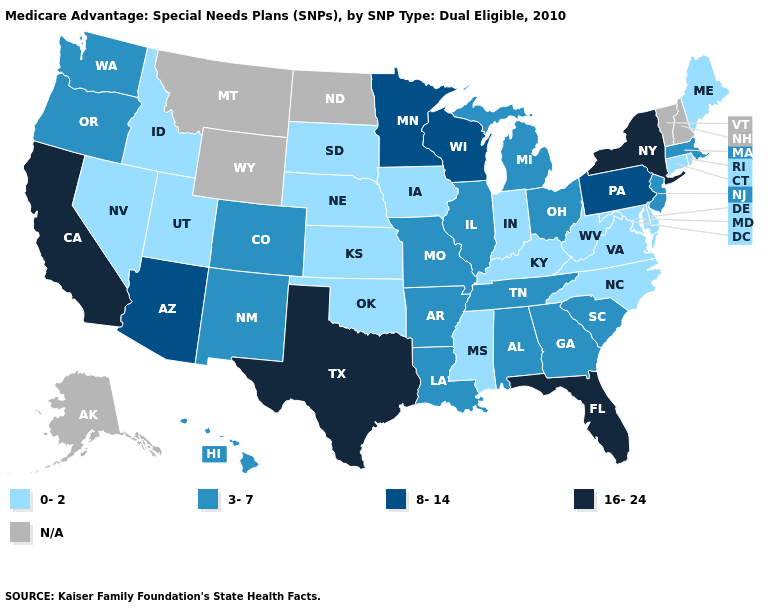How many symbols are there in the legend?
Be succinct. 5. Name the states that have a value in the range 3-7?
Give a very brief answer. Alabama, Arkansas, Colorado, Georgia, Hawaii, Illinois, Louisiana, Massachusetts, Michigan, Missouri, New Jersey, New Mexico, Ohio, Oregon, South Carolina, Tennessee, Washington. Does the first symbol in the legend represent the smallest category?
Be succinct. Yes. What is the value of Minnesota?
Concise answer only. 8-14. Does Utah have the lowest value in the USA?
Keep it brief. Yes. Name the states that have a value in the range 3-7?
Answer briefly. Alabama, Arkansas, Colorado, Georgia, Hawaii, Illinois, Louisiana, Massachusetts, Michigan, Missouri, New Jersey, New Mexico, Ohio, Oregon, South Carolina, Tennessee, Washington. What is the value of Minnesota?
Short answer required. 8-14. Name the states that have a value in the range 3-7?
Quick response, please. Alabama, Arkansas, Colorado, Georgia, Hawaii, Illinois, Louisiana, Massachusetts, Michigan, Missouri, New Jersey, New Mexico, Ohio, Oregon, South Carolina, Tennessee, Washington. What is the highest value in the USA?
Short answer required. 16-24. What is the value of Wyoming?
Be succinct. N/A. What is the highest value in the South ?
Quick response, please. 16-24. What is the value of Delaware?
Short answer required. 0-2. What is the lowest value in the USA?
Be succinct. 0-2. What is the value of Washington?
Answer briefly. 3-7. Does Michigan have the lowest value in the MidWest?
Short answer required. No. 